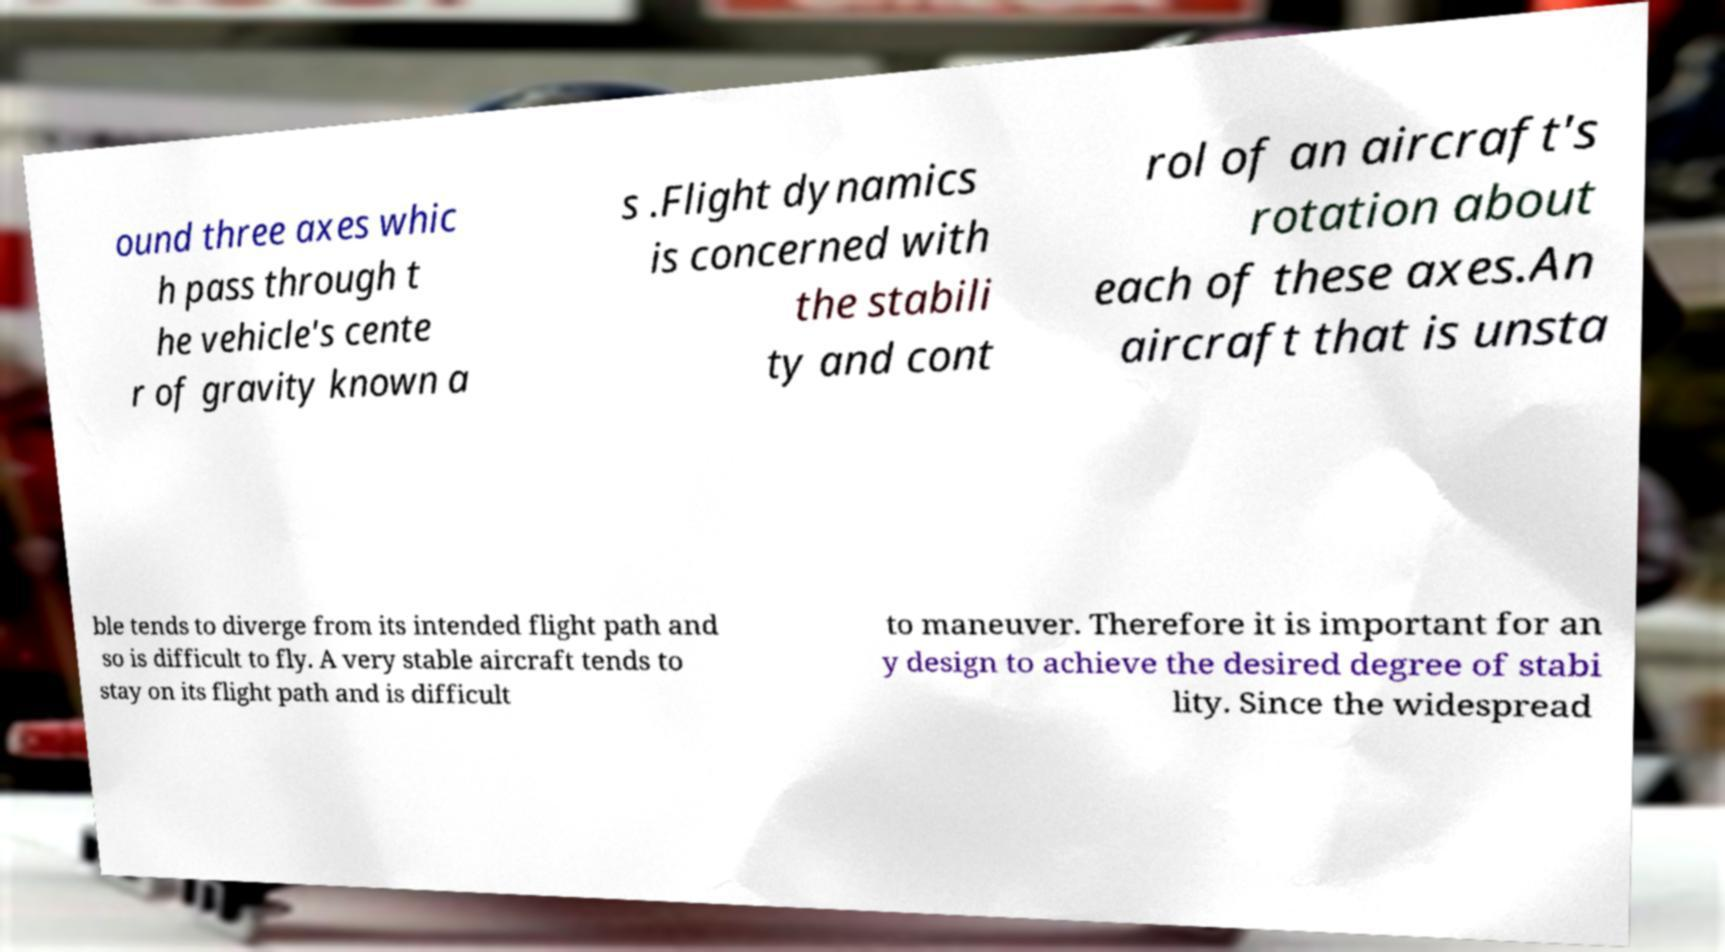I need the written content from this picture converted into text. Can you do that? ound three axes whic h pass through t he vehicle's cente r of gravity known a s .Flight dynamics is concerned with the stabili ty and cont rol of an aircraft's rotation about each of these axes.An aircraft that is unsta ble tends to diverge from its intended flight path and so is difficult to fly. A very stable aircraft tends to stay on its flight path and is difficult to maneuver. Therefore it is important for an y design to achieve the desired degree of stabi lity. Since the widespread 